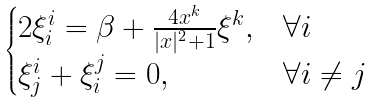Convert formula to latex. <formula><loc_0><loc_0><loc_500><loc_500>\begin{cases} 2 \xi ^ { i } _ { i } = \beta + \frac { 4 x ^ { k } } { | x | ^ { 2 } + 1 } \xi ^ { k } , & \forall i \\ \xi ^ { i } _ { j } + \xi ^ { j } _ { i } = 0 , & \forall i \not = j \end{cases}</formula> 